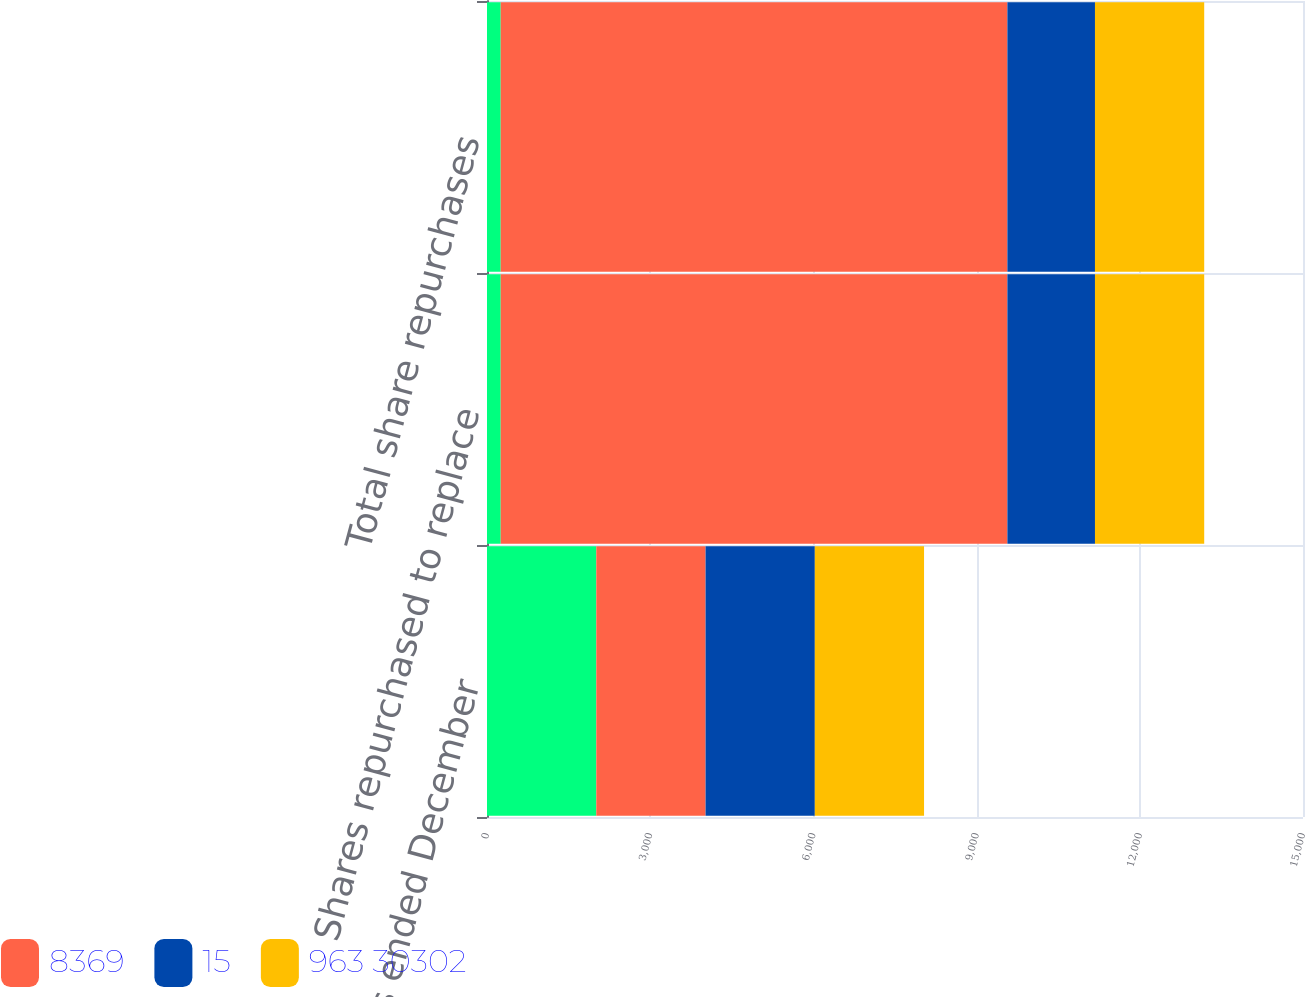Convert chart. <chart><loc_0><loc_0><loc_500><loc_500><stacked_bar_chart><ecel><fcel>For the years ended December<fcel>Shares repurchased to replace<fcel>Total share repurchases<nl><fcel>nan<fcel>2009<fcel>252<fcel>252<nl><fcel>8369<fcel>2009<fcel>9314<fcel>9314<nl><fcel>15<fcel>2008<fcel>1610<fcel>1610<nl><fcel>963 30302<fcel>2008<fcel>2008<fcel>2008<nl></chart> 